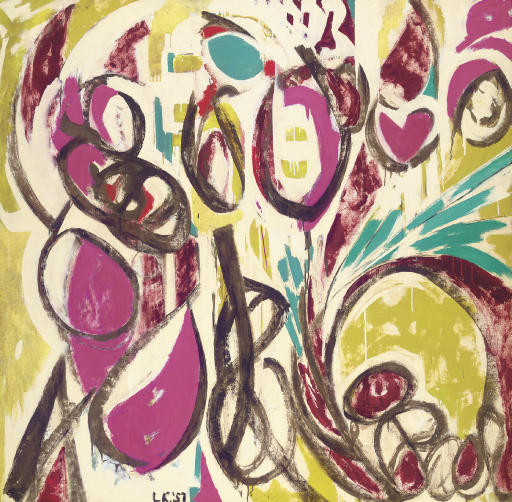What emotions do you think this painting is trying to invoke? The painting appears to evoke a sense of excitement and energy, potentially highlighting themes of chaos and freedom. The vigorous use of bold, contrasting colors and dynamic shapes might stir feelings of joy and optimism, while also portraying an undercurrent of unpredictability and spontaneity. 